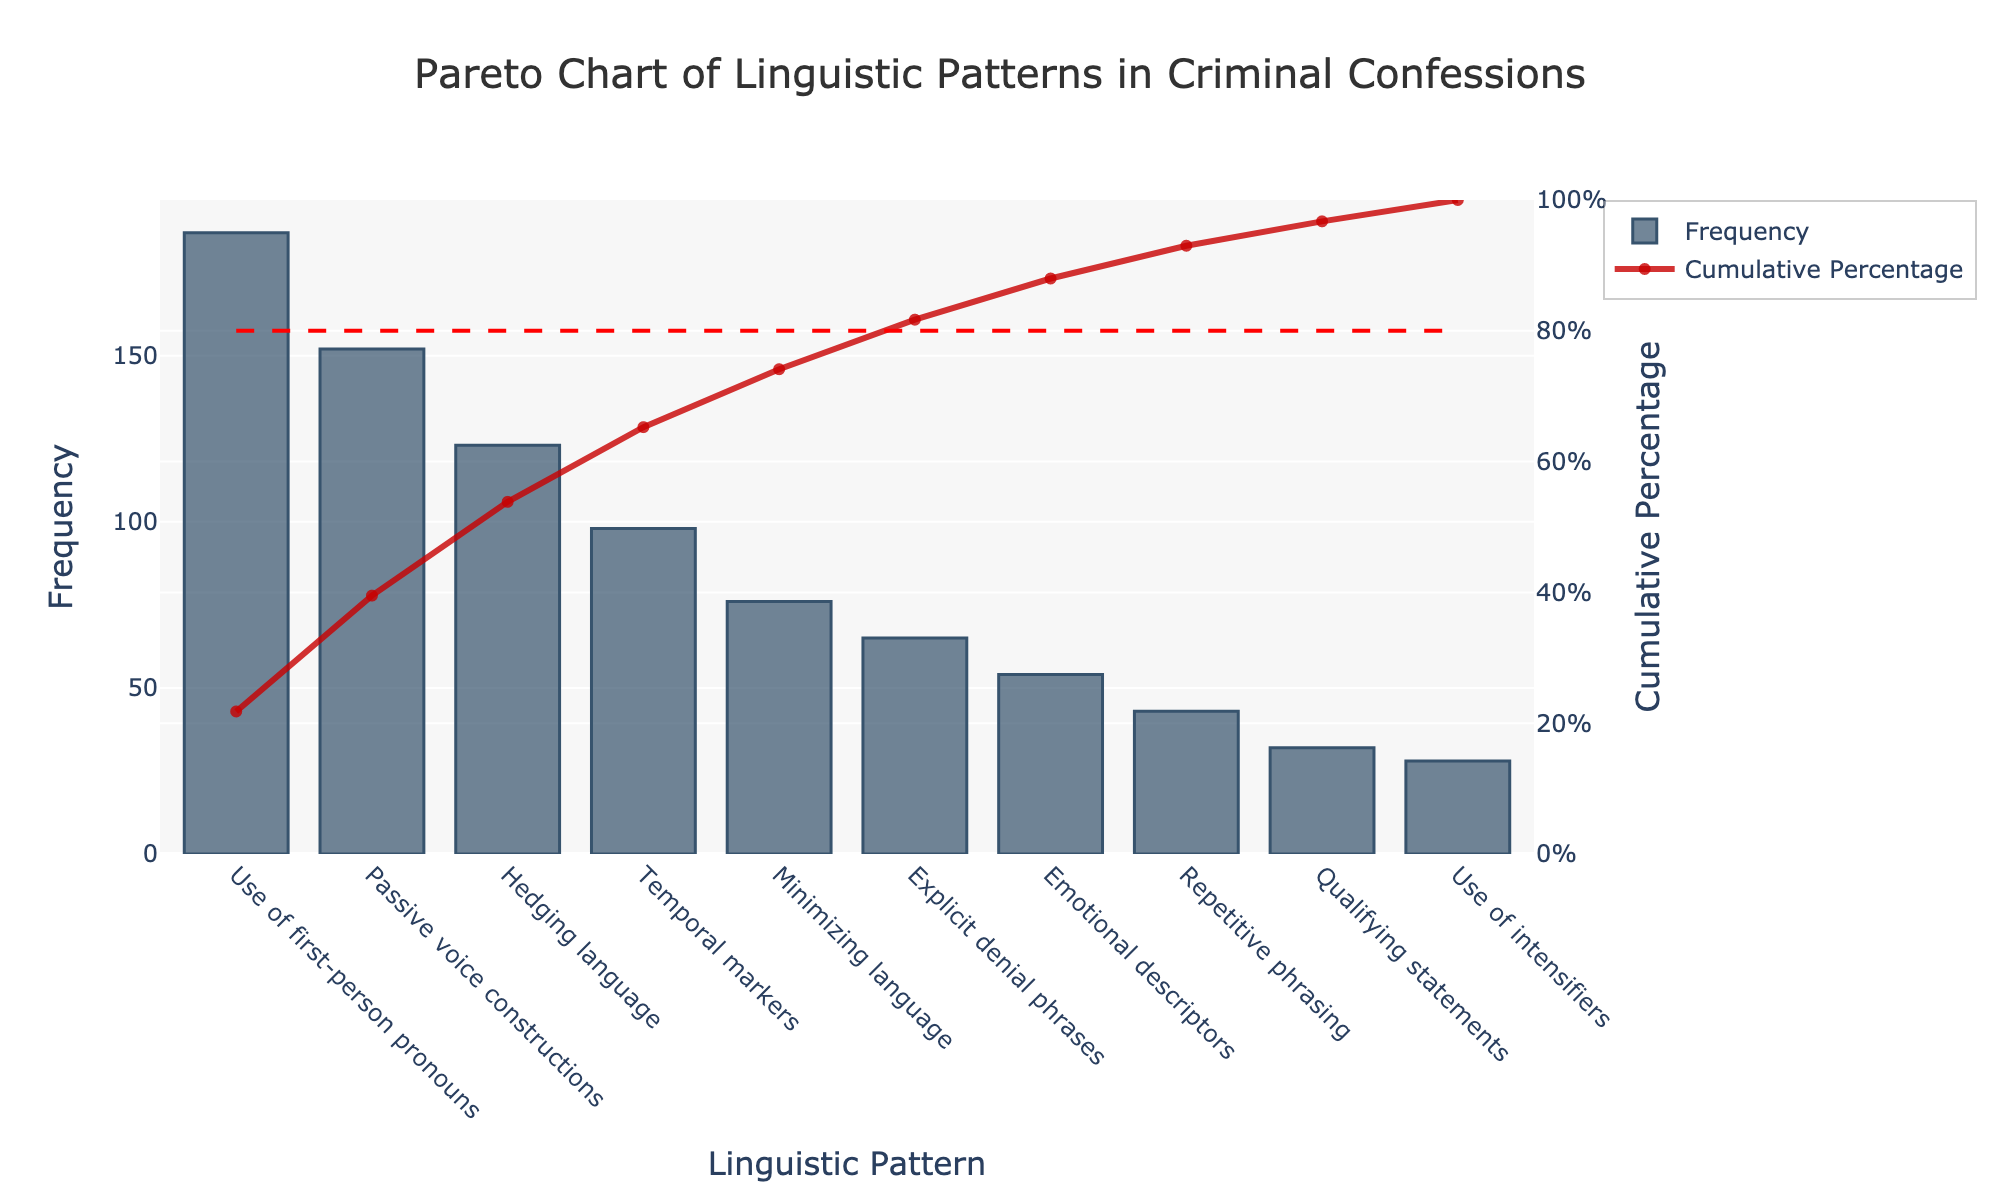What is the title of the figure? The title is displayed at the top of the chart and reads "Pareto Chart of Linguistic Patterns in Criminal Confessions".
Answer: Pareto Chart of Linguistic Patterns in Criminal Confessions Which linguistic pattern has the highest frequency? The bar chart shows the frequencies of linguistic patterns. The tallest bar represents the "Use of first-person pronouns".
Answer: Use of first-person pronouns What is the cumulative percentage after the five most frequent patterns? Sum the frequencies of the top five patterns (187 + 152 + 123 + 98 + 76) = 636, then divide by the total sum (187 + 152 + 123 + 98 + 76 + 65 + 54 + 43 + 32 + 28) = 858, and multiply by 100 to get the percentage.
Answer: Around 74% How many linguistic patterns cumulatively account for approximately 80% of the occurrences? Follow the cumulative percentage line and count the number of patterns until the line crosses the 80% threshold. Approximately 6 patterns account for this.
Answer: 6 Which linguistic pattern is the 3rd most frequent? The bars are ordered by frequency in descending order. The 3rd tallest bar represents "Hedging language".
Answer: Hedging language What is the frequency difference between Passive voice constructions and Explicit denial phrases? Subtract the frequency of Explicit denial phrases (65) from that of Passive voice constructions (152): 152 - 65.
Answer: 87 What percentage of the total frequency does the "Use of intensifiers" represent? The frequency of Use of intensifiers is 28. Divide this by the total frequency sum (858) and multiply by 100 to get the percentage.
Answer: Around 3.3% What does the red dashed line in the chart represent? The red dashed line is located at the 80% mark on the cumulative percentage axis, indicating the 80% threshold.
Answer: 80% threshold 